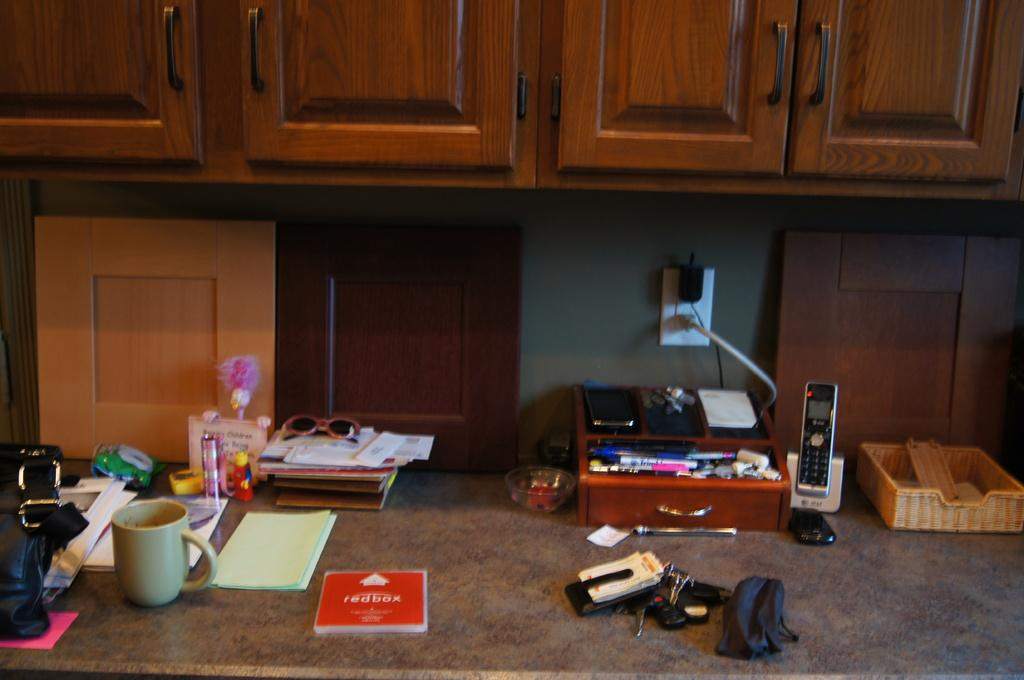What is one object that can be seen in the image? There is a cup in the image. What type of window covering is present in the image? There are shades in the image. What type of items can be seen on a surface in the image? There are books in the image. What type of furniture is visible in the image? There are wooden cupboards in the image. What type of objects are attached to the wall in the image? There are other objects attached to the wall in the image. What color is the paint on the wall in the image? There is no mention of paint or a specific color on the wall in the image. 